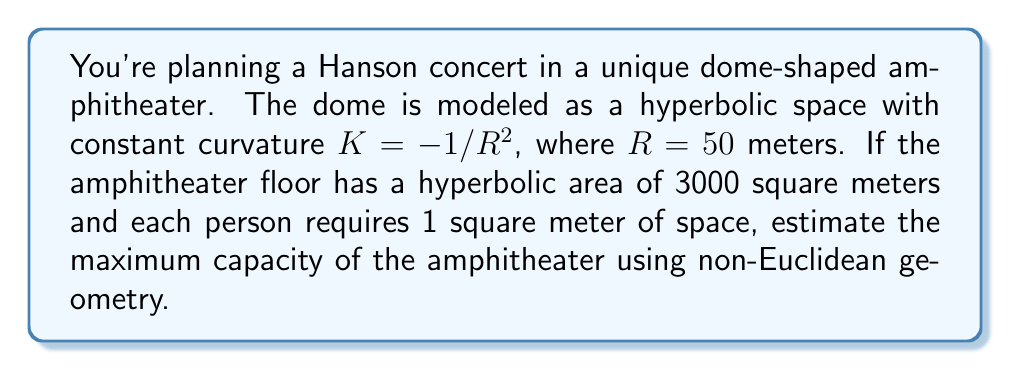Can you answer this question? To solve this problem, we'll use concepts from hyperbolic geometry:

1) In hyperbolic geometry, the area $A$ of a circle with radius $r$ in a space with curvature $K = -1/R^2$ is given by:

   $$A = 4\pi R^2 \sinh^2(\frac{r}{2R})$$

2) We're given that the area is 3000 m², so:

   $$3000 = 4\pi (50)^2 \sinh^2(\frac{r}{2(50)})$$

3) Simplify:

   $$3000 = 10000\pi \sinh^2(\frac{r}{100})$$

4) Solve for $\sinh^2(\frac{r}{100})$:

   $$\sinh^2(\frac{r}{100}) = \frac{3000}{10000\pi} \approx 0.0955$$

5) Take the square root and inverse hyperbolic sine:

   $$\frac{r}{100} = \text{arcsinh}(\sqrt{0.0955}) \approx 0.3102$$

6) Solve for $r$:

   $$r \approx 31.02 \text{ meters}$$

7) This radius represents the hyperbolic radius of the amphitheater floor. To estimate capacity, we divide the given area by the space required per person:

   $$\text{Capacity} = \frac{3000 \text{ m}^2}{1 \text{ m}^2/\text{person}} = 3000 \text{ people}$$
Answer: 3000 people 